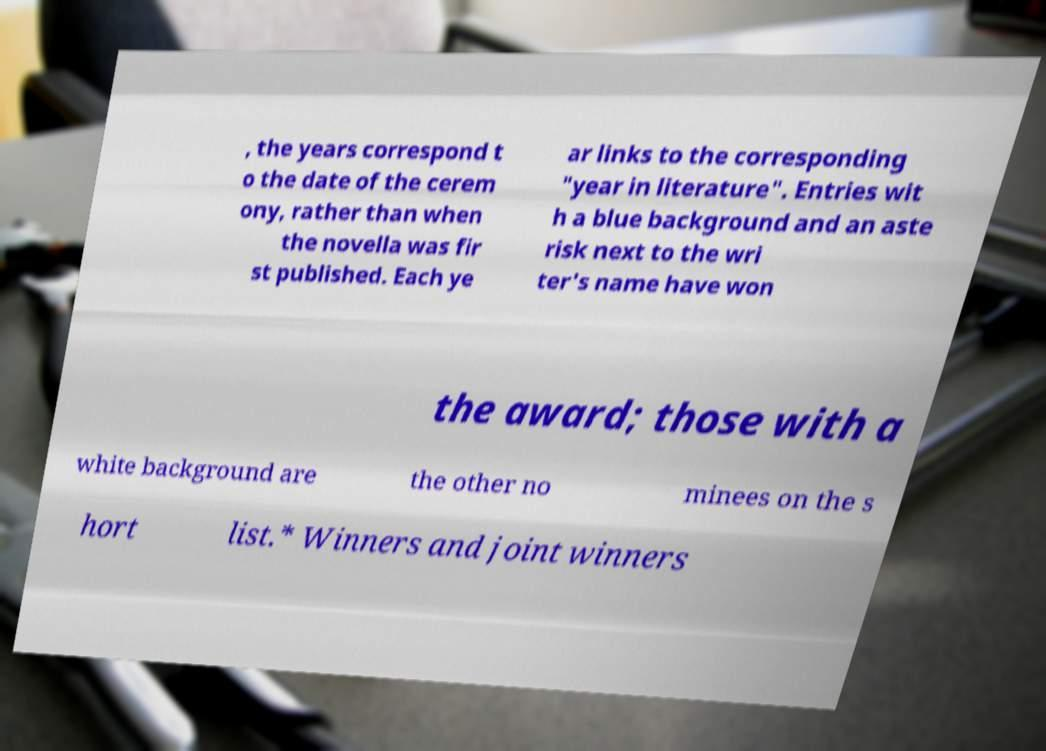Please identify and transcribe the text found in this image. , the years correspond t o the date of the cerem ony, rather than when the novella was fir st published. Each ye ar links to the corresponding "year in literature". Entries wit h a blue background and an aste risk next to the wri ter's name have won the award; those with a white background are the other no minees on the s hort list.* Winners and joint winners 